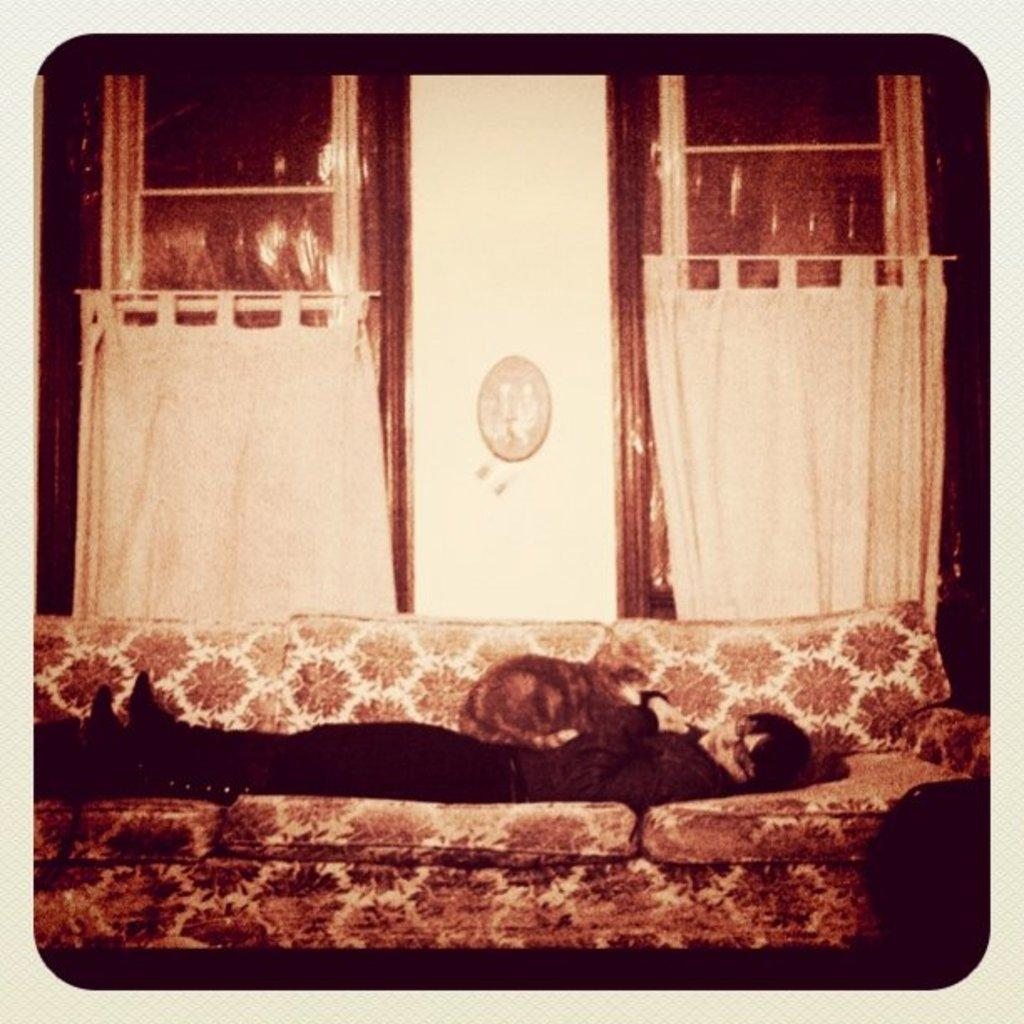What is the person in the image doing? The person is lying on a sofa in the image. Is there any animal with the person? Yes, there is a cat with the person in the image. What can be seen in the background of the image? There are curtains, a window, and a photo frame on the wall in the background. What type of meat is the person eating in the image? There is no meat present in the image; the person is lying on a sofa with a cat. 